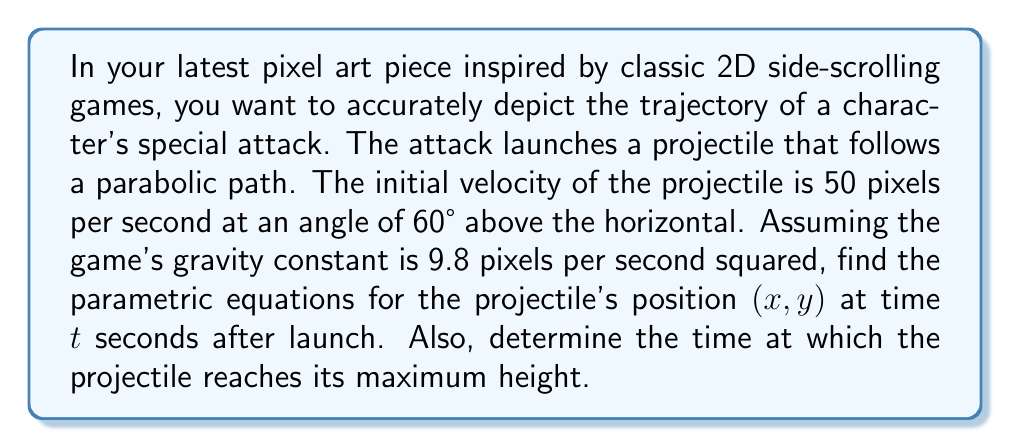Give your solution to this math problem. Let's approach this step-by-step:

1) First, we need to break down the initial velocity into its horizontal and vertical components:

   $v_0x = v_0 \cos \theta = 50 \cos 60° = 25$ pixels/second
   $v_0y = v_0 \sin \theta = 50 \sin 60° = 43.3$ pixels/second

2) The parametric equations for a projectile's motion are:

   $x(t) = v_0x t$
   $y(t) = v_0y t - \frac{1}{2}gt^2$

   Where $g$ is the acceleration due to gravity.

3) Substituting our values:

   $x(t) = 25t$
   $y(t) = 43.3t - \frac{1}{2}(9.8)t^2 = 43.3t - 4.9t^2$

4) To find the time at maximum height, we need to find when the vertical velocity is zero:

   $\frac{dy}{dt} = 43.3 - 9.8t = 0$
   $43.3 - 9.8t = 0$
   $9.8t = 43.3$
   $t = \frac{43.3}{9.8} = 4.42$ seconds

Therefore, the projectile reaches its maximum height at approximately 4.42 seconds after launch.
Answer: The parametric equations are:

$$x(t) = 25t$$
$$y(t) = 43.3t - 4.9t^2$$

The projectile reaches its maximum height at $t \approx 4.42$ seconds. 